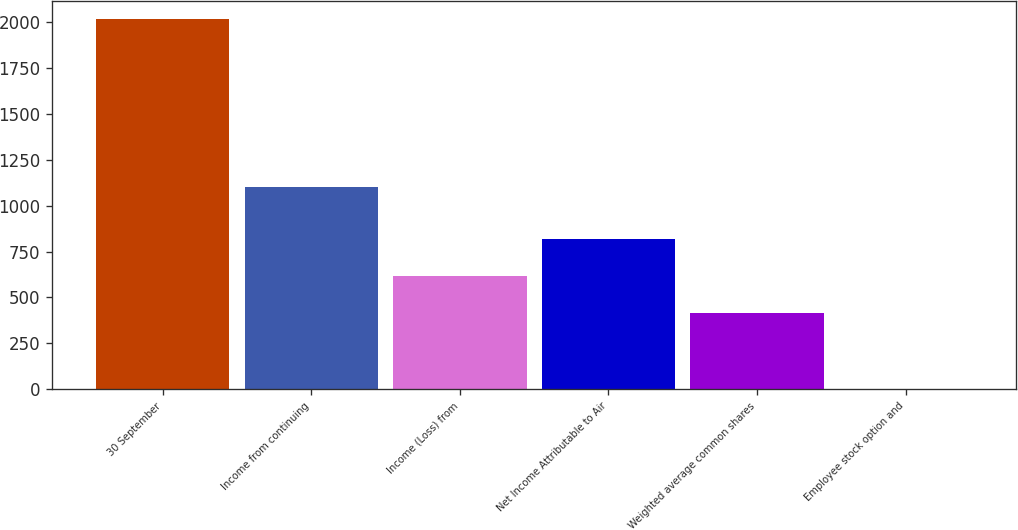Convert chart to OTSL. <chart><loc_0><loc_0><loc_500><loc_500><bar_chart><fcel>30 September<fcel>Income from continuing<fcel>Income (Loss) from<fcel>Net Income Attributable to Air<fcel>Weighted average common shares<fcel>Employee stock option and<nl><fcel>2016<fcel>1099.5<fcel>619.22<fcel>820.63<fcel>417.81<fcel>1.9<nl></chart> 